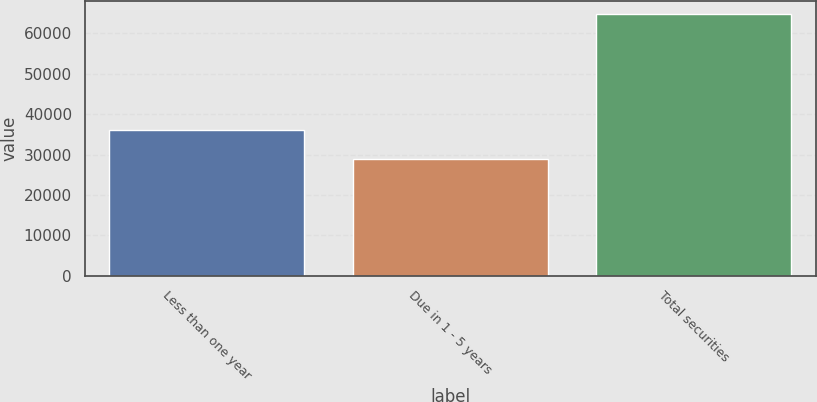Convert chart to OTSL. <chart><loc_0><loc_0><loc_500><loc_500><bar_chart><fcel>Less than one year<fcel>Due in 1 - 5 years<fcel>Total securities<nl><fcel>36062<fcel>28801<fcel>64863<nl></chart> 